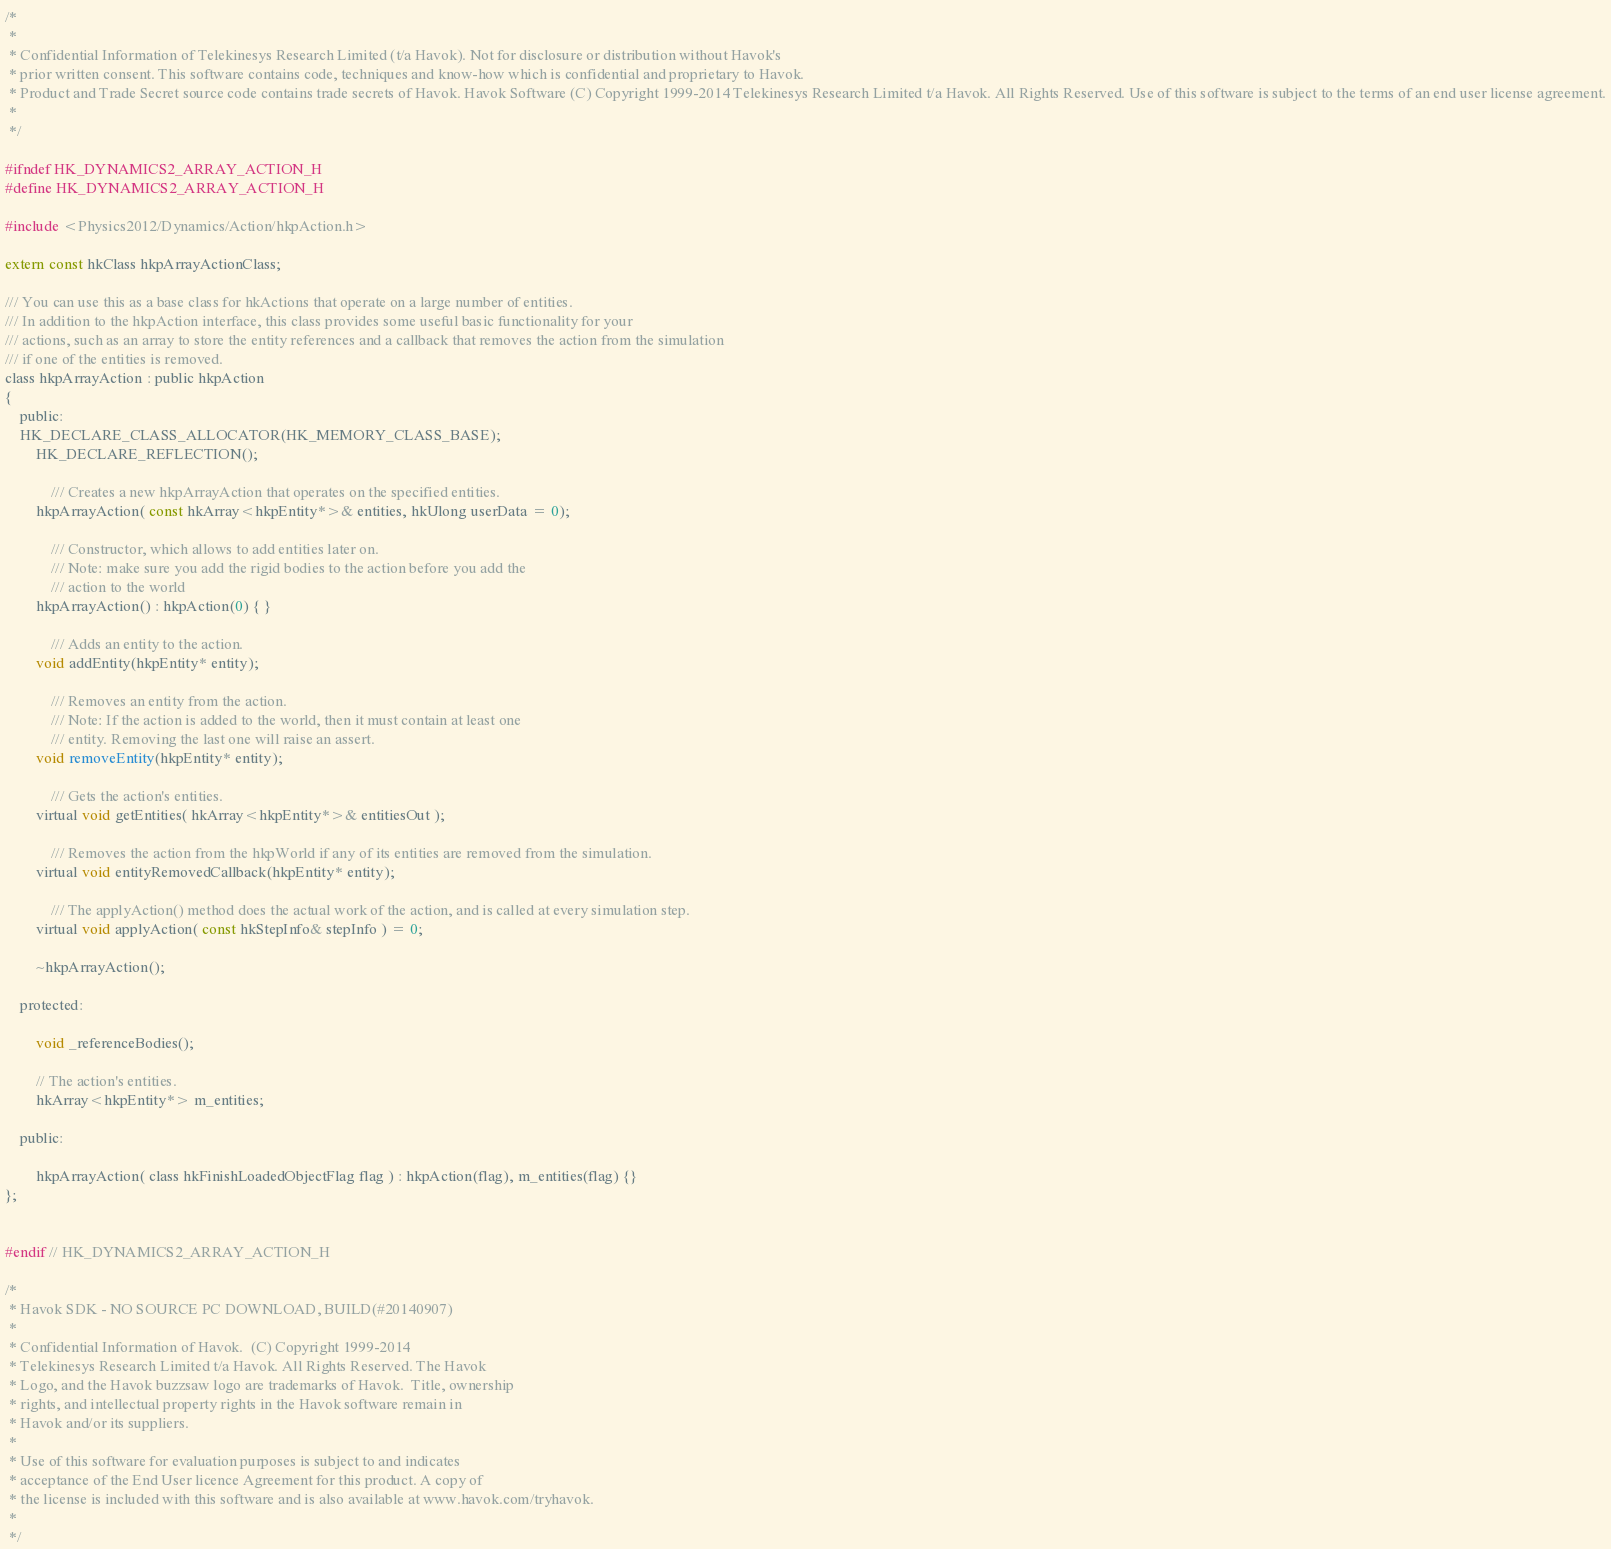<code> <loc_0><loc_0><loc_500><loc_500><_C_>/*
 *
 * Confidential Information of Telekinesys Research Limited (t/a Havok). Not for disclosure or distribution without Havok's
 * prior written consent. This software contains code, techniques and know-how which is confidential and proprietary to Havok.
 * Product and Trade Secret source code contains trade secrets of Havok. Havok Software (C) Copyright 1999-2014 Telekinesys Research Limited t/a Havok. All Rights Reserved. Use of this software is subject to the terms of an end user license agreement.
 *
 */

#ifndef HK_DYNAMICS2_ARRAY_ACTION_H
#define HK_DYNAMICS2_ARRAY_ACTION_H

#include <Physics2012/Dynamics/Action/hkpAction.h>

extern const hkClass hkpArrayActionClass;

/// You can use this as a base class for hkActions that operate on a large number of entities.
/// In addition to the hkpAction interface, this class provides some useful basic functionality for your
/// actions, such as an array to store the entity references and a callback that removes the action from the simulation
/// if one of the entities is removed.
class hkpArrayAction : public hkpAction
{
	public:
	HK_DECLARE_CLASS_ALLOCATOR(HK_MEMORY_CLASS_BASE);
		HK_DECLARE_REFLECTION();
	
			/// Creates a new hkpArrayAction that operates on the specified entities.
		hkpArrayAction( const hkArray<hkpEntity*>& entities, hkUlong userData = 0);

			/// Constructor, which allows to add entities later on.
			/// Note: make sure you add the rigid bodies to the action before you add the
			/// action to the world
		hkpArrayAction() : hkpAction(0) { }
		
			/// Adds an entity to the action.
		void addEntity(hkpEntity* entity);

			/// Removes an entity from the action.
			/// Note: If the action is added to the world, then it must contain at least one
			/// entity. Removing the last one will raise an assert.
		void removeEntity(hkpEntity* entity);
	
			/// Gets the action's entities.
		virtual void getEntities( hkArray<hkpEntity*>& entitiesOut );

			/// Removes the action from the hkpWorld if any of its entities are removed from the simulation.
		virtual void entityRemovedCallback(hkpEntity* entity);
		
			/// The applyAction() method does the actual work of the action, and is called at every simulation step.
		virtual void applyAction( const hkStepInfo& stepInfo ) = 0;

		~hkpArrayAction();

	protected:

		void _referenceBodies(); 

		// The action's entities.
		hkArray<hkpEntity*> m_entities;

	public:

		hkpArrayAction( class hkFinishLoadedObjectFlag flag ) : hkpAction(flag), m_entities(flag) {}
};


#endif // HK_DYNAMICS2_ARRAY_ACTION_H

/*
 * Havok SDK - NO SOURCE PC DOWNLOAD, BUILD(#20140907)
 * 
 * Confidential Information of Havok.  (C) Copyright 1999-2014
 * Telekinesys Research Limited t/a Havok. All Rights Reserved. The Havok
 * Logo, and the Havok buzzsaw logo are trademarks of Havok.  Title, ownership
 * rights, and intellectual property rights in the Havok software remain in
 * Havok and/or its suppliers.
 * 
 * Use of this software for evaluation purposes is subject to and indicates
 * acceptance of the End User licence Agreement for this product. A copy of
 * the license is included with this software and is also available at www.havok.com/tryhavok.
 * 
 */
</code> 